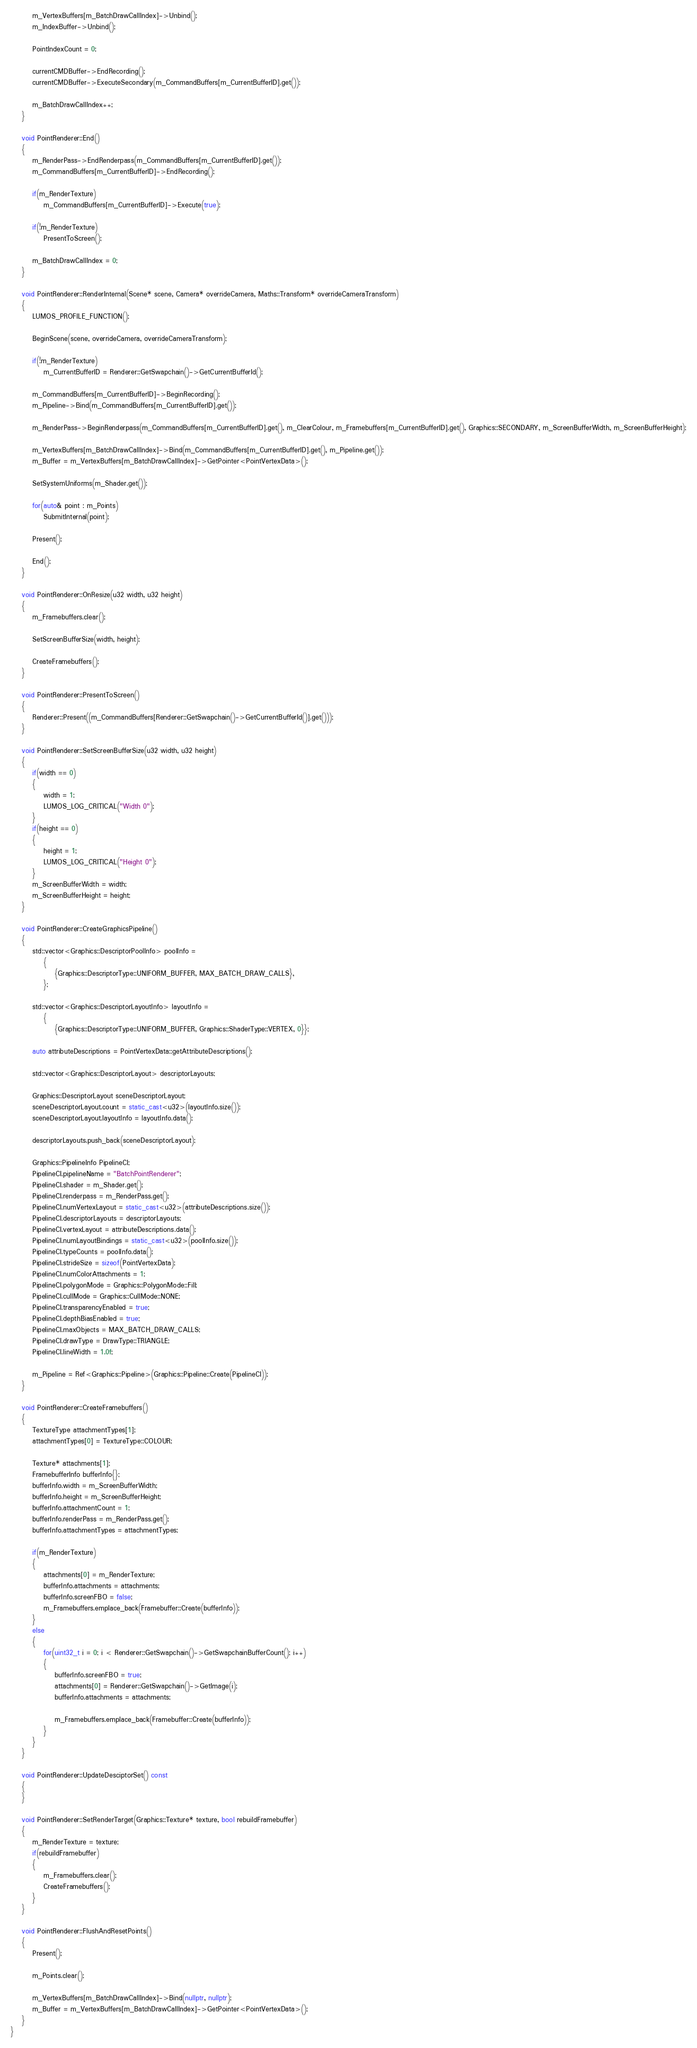Convert code to text. <code><loc_0><loc_0><loc_500><loc_500><_C++_>		m_VertexBuffers[m_BatchDrawCallIndex]->Unbind();
		m_IndexBuffer->Unbind();

		PointIndexCount = 0;

		currentCMDBuffer->EndRecording();
		currentCMDBuffer->ExecuteSecondary(m_CommandBuffers[m_CurrentBufferID].get());

		m_BatchDrawCallIndex++;
	}

	void PointRenderer::End()
	{
		m_RenderPass->EndRenderpass(m_CommandBuffers[m_CurrentBufferID].get());
		m_CommandBuffers[m_CurrentBufferID]->EndRecording();

		if(m_RenderTexture)
			m_CommandBuffers[m_CurrentBufferID]->Execute(true);

		if(!m_RenderTexture)
			PresentToScreen();

		m_BatchDrawCallIndex = 0;
	}

	void PointRenderer::RenderInternal(Scene* scene, Camera* overrideCamera, Maths::Transform* overrideCameraTransform)
	{
		LUMOS_PROFILE_FUNCTION();

		BeginScene(scene, overrideCamera, overrideCameraTransform);

		if(!m_RenderTexture)
			m_CurrentBufferID = Renderer::GetSwapchain()->GetCurrentBufferId();

		m_CommandBuffers[m_CurrentBufferID]->BeginRecording();
        m_Pipeline->Bind(m_CommandBuffers[m_CurrentBufferID].get());

        m_RenderPass->BeginRenderpass(m_CommandBuffers[m_CurrentBufferID].get(), m_ClearColour, m_Framebuffers[m_CurrentBufferID].get(), Graphics::SECONDARY, m_ScreenBufferWidth, m_ScreenBufferHeight);

        m_VertexBuffers[m_BatchDrawCallIndex]->Bind(m_CommandBuffers[m_CurrentBufferID].get(), m_Pipeline.get());
		m_Buffer = m_VertexBuffers[m_BatchDrawCallIndex]->GetPointer<PointVertexData>();

		SetSystemUniforms(m_Shader.get());

		for(auto& point : m_Points)
			SubmitInternal(point);

		Present();

		End();
	}

	void PointRenderer::OnResize(u32 width, u32 height)
	{
		m_Framebuffers.clear();

		SetScreenBufferSize(width, height);

		CreateFramebuffers();
	}

	void PointRenderer::PresentToScreen()
	{
		Renderer::Present((m_CommandBuffers[Renderer::GetSwapchain()->GetCurrentBufferId()].get()));
	}

	void PointRenderer::SetScreenBufferSize(u32 width, u32 height)
	{
		if(width == 0)
		{
			width = 1;
			LUMOS_LOG_CRITICAL("Width 0");
		}
		if(height == 0)
		{
			height = 1;
			LUMOS_LOG_CRITICAL("Height 0");
		}
		m_ScreenBufferWidth = width;
		m_ScreenBufferHeight = height;
	}

	void PointRenderer::CreateGraphicsPipeline()
	{
		std::vector<Graphics::DescriptorPoolInfo> poolInfo =
			{
				{Graphics::DescriptorType::UNIFORM_BUFFER, MAX_BATCH_DRAW_CALLS},
			};

		std::vector<Graphics::DescriptorLayoutInfo> layoutInfo =
			{
				{Graphics::DescriptorType::UNIFORM_BUFFER, Graphics::ShaderType::VERTEX, 0}};

		auto attributeDescriptions = PointVertexData::getAttributeDescriptions();

		std::vector<Graphics::DescriptorLayout> descriptorLayouts;

		Graphics::DescriptorLayout sceneDescriptorLayout;
		sceneDescriptorLayout.count = static_cast<u32>(layoutInfo.size());
		sceneDescriptorLayout.layoutInfo = layoutInfo.data();

		descriptorLayouts.push_back(sceneDescriptorLayout);

		Graphics::PipelineInfo PipelineCI;
		PipelineCI.pipelineName = "BatchPointRenderer";
		PipelineCI.shader = m_Shader.get();
		PipelineCI.renderpass = m_RenderPass.get();
		PipelineCI.numVertexLayout = static_cast<u32>(attributeDescriptions.size());
		PipelineCI.descriptorLayouts = descriptorLayouts;
		PipelineCI.vertexLayout = attributeDescriptions.data();
		PipelineCI.numLayoutBindings = static_cast<u32>(poolInfo.size());
		PipelineCI.typeCounts = poolInfo.data();
		PipelineCI.strideSize = sizeof(PointVertexData);
		PipelineCI.numColorAttachments = 1;
		PipelineCI.polygonMode = Graphics::PolygonMode::Fill;
		PipelineCI.cullMode = Graphics::CullMode::NONE;
		PipelineCI.transparencyEnabled = true;
		PipelineCI.depthBiasEnabled = true;
		PipelineCI.maxObjects = MAX_BATCH_DRAW_CALLS;
		PipelineCI.drawType = DrawType::TRIANGLE;
		PipelineCI.lineWidth = 1.0f;

		m_Pipeline = Ref<Graphics::Pipeline>(Graphics::Pipeline::Create(PipelineCI));
	}

	void PointRenderer::CreateFramebuffers()
	{
		TextureType attachmentTypes[1];
		attachmentTypes[0] = TextureType::COLOUR;

		Texture* attachments[1];
		FramebufferInfo bufferInfo{};
		bufferInfo.width = m_ScreenBufferWidth;
		bufferInfo.height = m_ScreenBufferHeight;
		bufferInfo.attachmentCount = 1;
		bufferInfo.renderPass = m_RenderPass.get();
		bufferInfo.attachmentTypes = attachmentTypes;

		if(m_RenderTexture)
		{
			attachments[0] = m_RenderTexture;
			bufferInfo.attachments = attachments;
			bufferInfo.screenFBO = false;
			m_Framebuffers.emplace_back(Framebuffer::Create(bufferInfo));
		}
		else
		{
			for(uint32_t i = 0; i < Renderer::GetSwapchain()->GetSwapchainBufferCount(); i++)
			{
				bufferInfo.screenFBO = true;
				attachments[0] = Renderer::GetSwapchain()->GetImage(i);
				bufferInfo.attachments = attachments;

				m_Framebuffers.emplace_back(Framebuffer::Create(bufferInfo));
			}
		}
	}

	void PointRenderer::UpdateDesciptorSet() const
	{
	}

	void PointRenderer::SetRenderTarget(Graphics::Texture* texture, bool rebuildFramebuffer)
	{
		m_RenderTexture = texture;
		if(rebuildFramebuffer)
		{
			m_Framebuffers.clear();
			CreateFramebuffers();
		}
	}

	void PointRenderer::FlushAndResetPoints()
	{
		Present();

		m_Points.clear();

		m_VertexBuffers[m_BatchDrawCallIndex]->Bind(nullptr, nullptr);
		m_Buffer = m_VertexBuffers[m_BatchDrawCallIndex]->GetPointer<PointVertexData>();
	}
}
</code> 